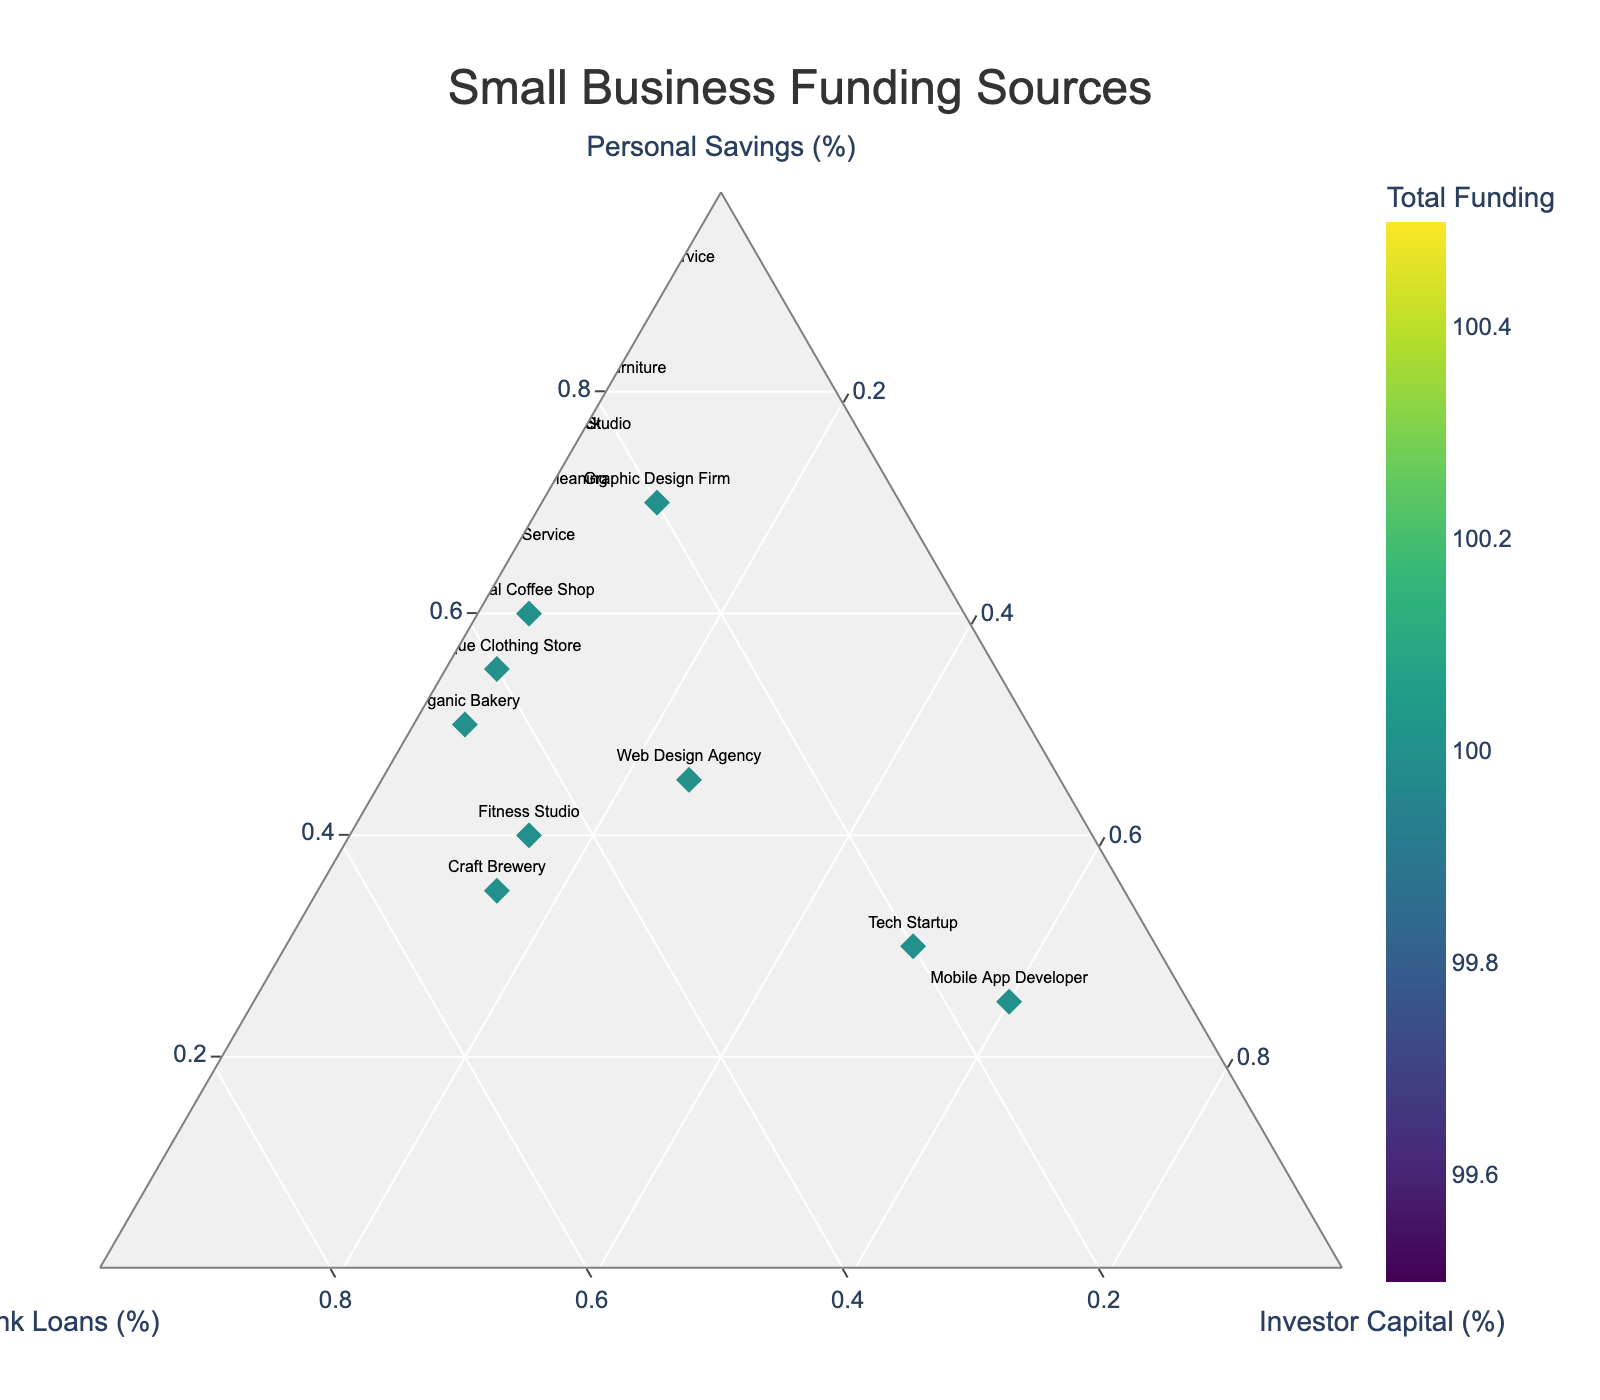What is the title of the figure? The title is prominently displayed at the top of the figure and specifies what the plot is about. The title reads "Small Business Funding Sources."
Answer: Small Business Funding Sources What are the three funding sources represented in the figure? These funding sources correspond to the three axes of the ternary plot, which are labeled clearly. The funding sources are Personal Savings, Bank Loans, and Investor Capital.
Answer: Personal Savings, Bank Loans, Investor Capital Which business relies the most on Investor Capital? Look at the apex of the triangle where the Investor Capital percentage is highest. The business label closest to this point represents the one relying most on Investor Capital. This is "Mobile App Developer."
Answer: Mobile App Developer How many businesses have 0% funding from Investor Capital? Businesses with 0% Investor Capital will lie on the edge of the triangle opposite the Investor Capital apex. By counting these points, we find there are six such businesses.
Answer: Six Which business has the highest total funding? The color intensity on the plot reflects total funding, with brighter colors indicating higher totals. By looking at the brightest point, the highest total funding is with "Tech Startup" and "Mobile App Developer."
Answer: Tech Startup, Mobile App Developer Which business has an equal split between Personal Savings and Bank Loans? On the ternary plot, an equal split between two sources means the business is located near the line bisecting those two sides of the triangle. "Web Design Agency" has a notable balance in these two funding sources.
Answer: Web Design Agency What is the percentage of Bank Loans for the Eco-Friendly Cleaning business? Locate the Eco-Friendly Cleaning business on the plot and read the percentage on the Bank Loans axis. It corresponds to the point at 30%.
Answer: 30% How does the funding composition of Handmade Furniture compare with that of Food Truck? Handmade Furniture has a very high percentage of Personal Savings (80%) and no Investor Capital, whereas Food Truck also relies heavily on Personal Savings (75%) but has a bit of Bank Loans (25%) and no Investor Capital.
Answer: Handmade Furniture: 80% Personal Savings, 20% Bank Loans, 0% Investor Capital; Food Truck: 75% Personal Savings, 25% Bank Loans, 0% Investor Capital What business has the closest funding composition to the Local Coffee Shop? Identify the point for Local Coffee Shop and then find the business with a point nearest to this location. The Boutique Clothing Store, with its similar funding composition, is closest.
Answer: Boutique Clothing Store Is there any business that does not utilize Bank Loans? Look for businesses at the base of the axis corresponding to Bank Loans (0%). The points on this edge indicate businesses that do not use Bank Loans. Six businesses meet this criterion.
Answer: Six 